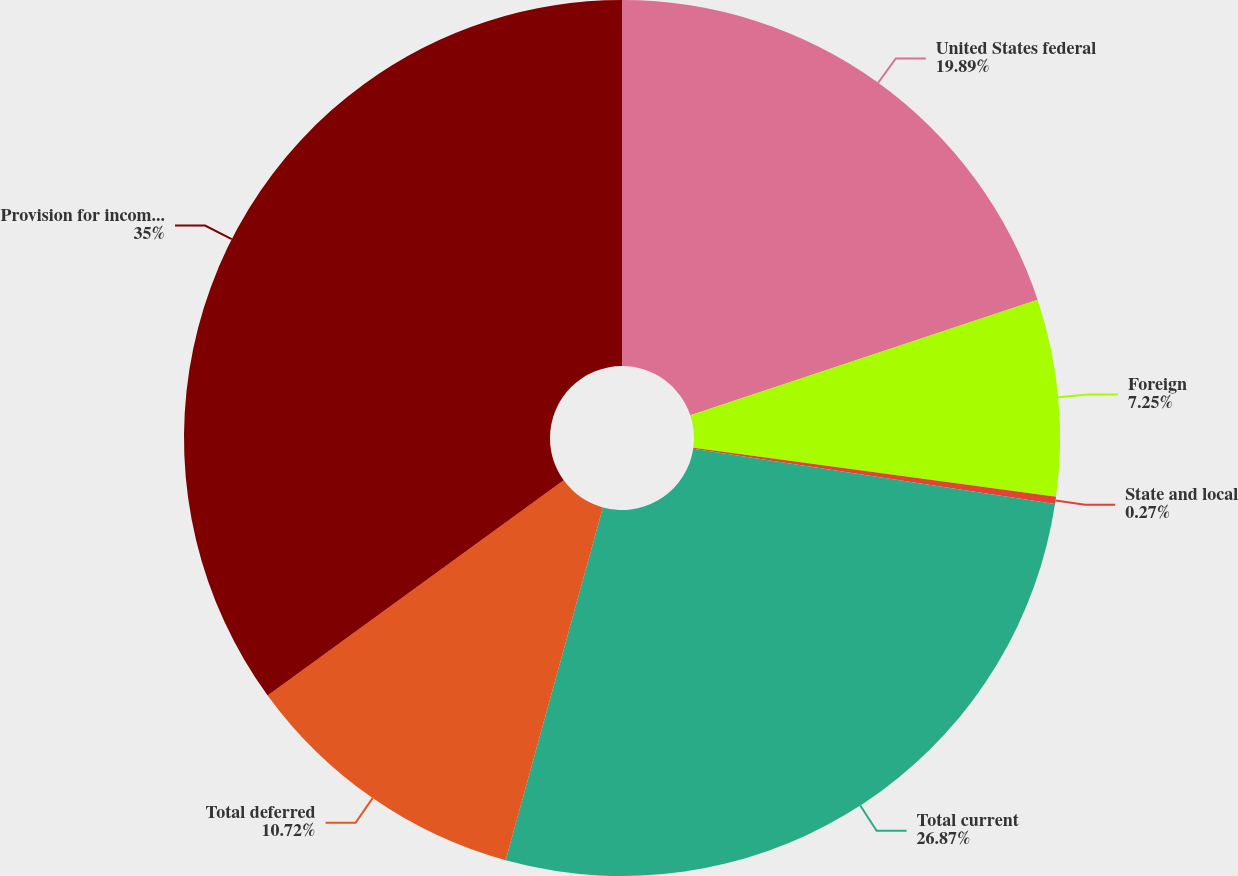<chart> <loc_0><loc_0><loc_500><loc_500><pie_chart><fcel>United States federal<fcel>Foreign<fcel>State and local<fcel>Total current<fcel>Total deferred<fcel>Provision for income taxes<nl><fcel>19.89%<fcel>7.25%<fcel>0.27%<fcel>26.87%<fcel>10.72%<fcel>35.0%<nl></chart> 